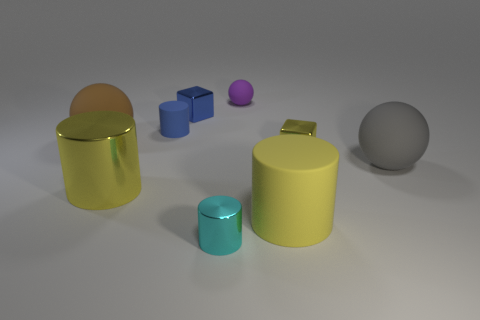Is there anything else that is the same material as the cyan cylinder?
Your answer should be compact. Yes. What is the size of the shiny thing that is the same color as the small matte cylinder?
Provide a short and direct response. Small. How big is the blue rubber cylinder?
Your response must be concise. Small. There is a large metal thing; is it the same color as the small metallic thing right of the purple thing?
Keep it short and to the point. Yes. There is a cube that is to the left of the yellow metallic block; is it the same size as the rubber cylinder behind the small yellow cube?
Offer a terse response. Yes. Is there a brown rubber cube of the same size as the purple ball?
Provide a short and direct response. No. There is a yellow metallic thing behind the large yellow metallic thing; is its shape the same as the tiny purple thing?
Provide a short and direct response. No. What material is the tiny cylinder in front of the big gray matte object?
Your answer should be compact. Metal. There is a tiny metal object that is behind the big matte ball that is to the left of the gray thing; what is its shape?
Make the answer very short. Cube. Does the large brown rubber thing have the same shape as the object behind the small blue shiny thing?
Ensure brevity in your answer.  Yes. 